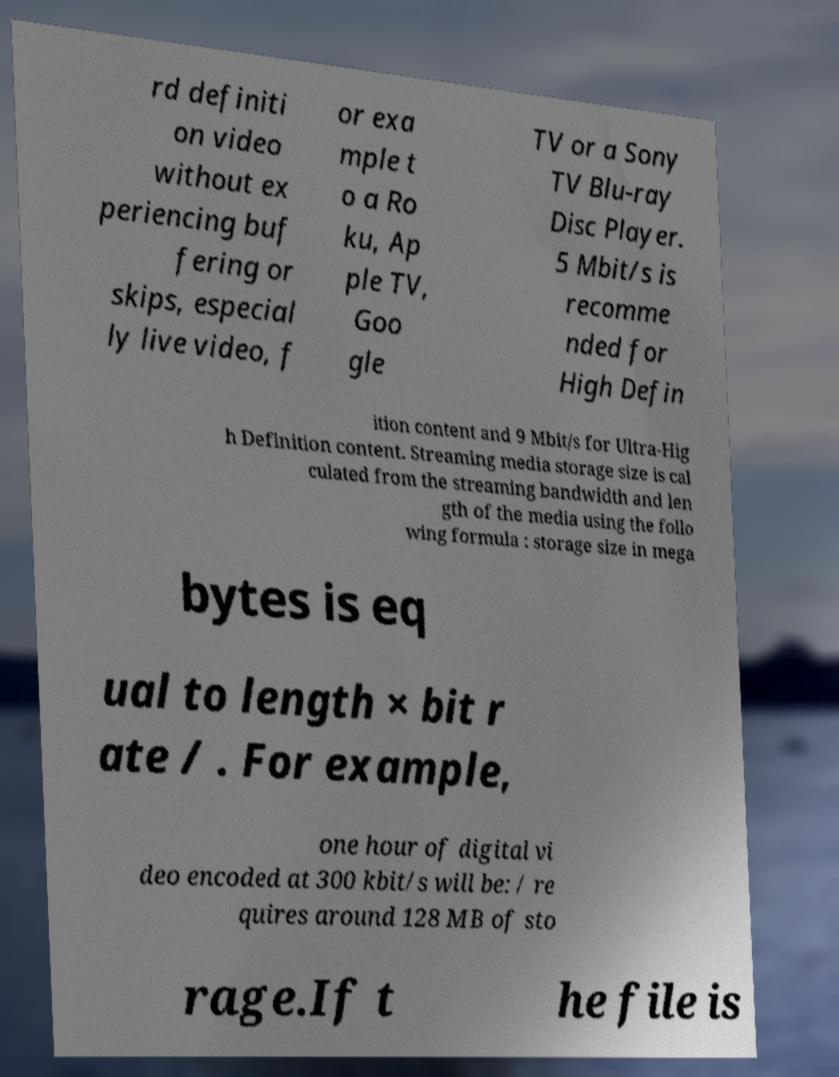Could you extract and type out the text from this image? rd definiti on video without ex periencing buf fering or skips, especial ly live video, f or exa mple t o a Ro ku, Ap ple TV, Goo gle TV or a Sony TV Blu-ray Disc Player. 5 Mbit/s is recomme nded for High Defin ition content and 9 Mbit/s for Ultra-Hig h Definition content. Streaming media storage size is cal culated from the streaming bandwidth and len gth of the media using the follo wing formula : storage size in mega bytes is eq ual to length × bit r ate / . For example, one hour of digital vi deo encoded at 300 kbit/s will be: / re quires around 128 MB of sto rage.If t he file is 